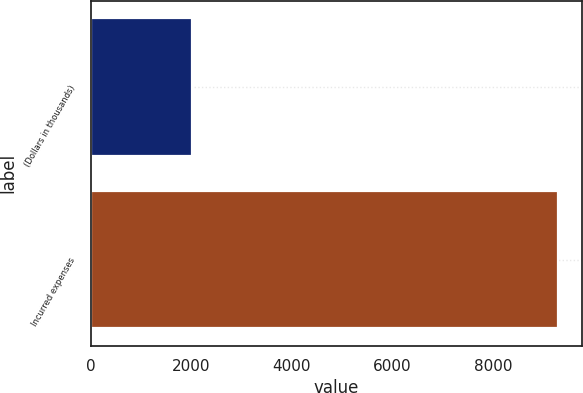Convert chart to OTSL. <chart><loc_0><loc_0><loc_500><loc_500><bar_chart><fcel>(Dollars in thousands)<fcel>Incurred expenses<nl><fcel>2018<fcel>9301<nl></chart> 